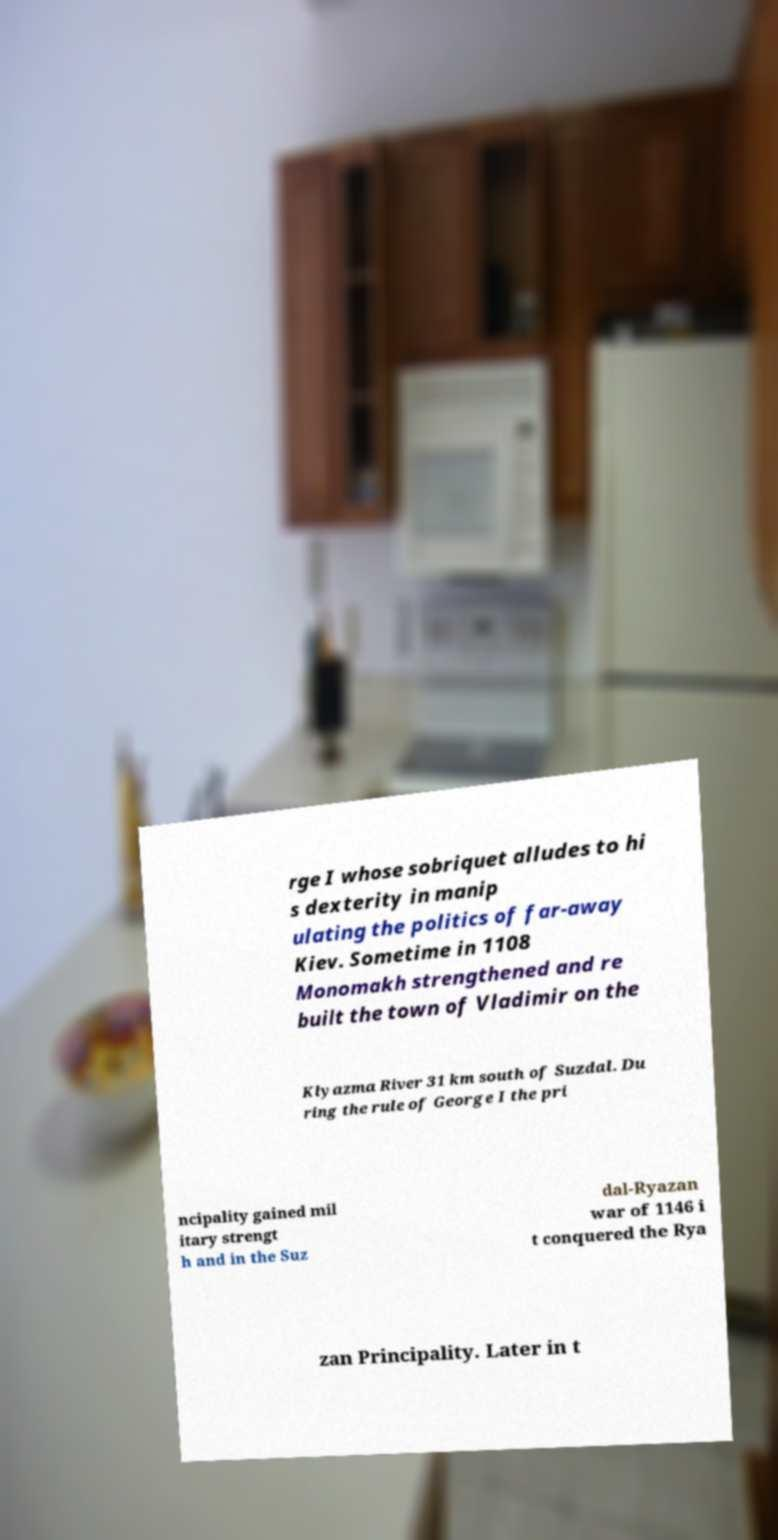Could you assist in decoding the text presented in this image and type it out clearly? rge I whose sobriquet alludes to hi s dexterity in manip ulating the politics of far-away Kiev. Sometime in 1108 Monomakh strengthened and re built the town of Vladimir on the Klyazma River 31 km south of Suzdal. Du ring the rule of George I the pri ncipality gained mil itary strengt h and in the Suz dal-Ryazan war of 1146 i t conquered the Rya zan Principality. Later in t 